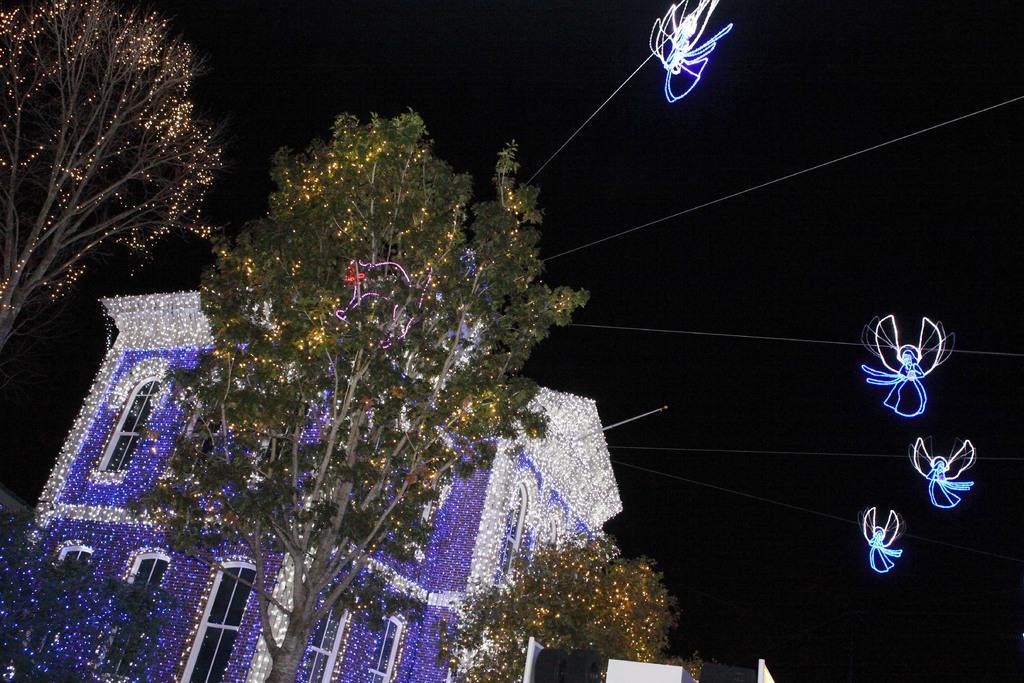How would you summarize this image in a sentence or two? In the picture we can see a night view of the building decorated with full of lights and near it, we can see some trees are also decorated with lights and some wires are also decorated with lights and behind we can see dark. 